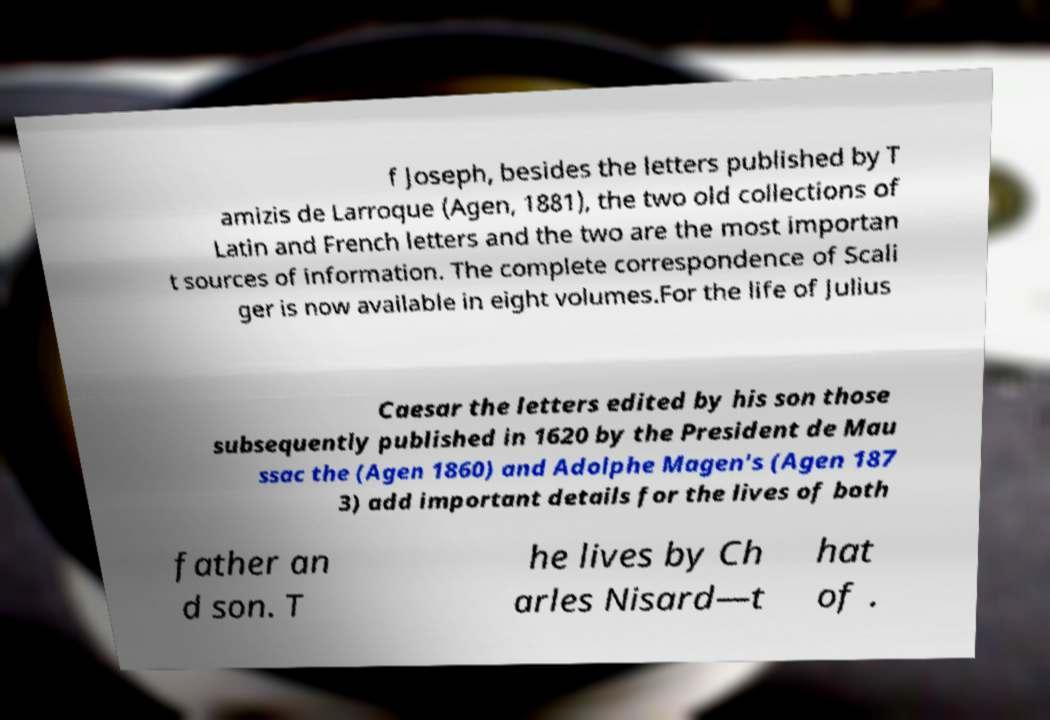Could you assist in decoding the text presented in this image and type it out clearly? f Joseph, besides the letters published by T amizis de Larroque (Agen, 1881), the two old collections of Latin and French letters and the two are the most importan t sources of information. The complete correspondence of Scali ger is now available in eight volumes.For the life of Julius Caesar the letters edited by his son those subsequently published in 1620 by the President de Mau ssac the (Agen 1860) and Adolphe Magen's (Agen 187 3) add important details for the lives of both father an d son. T he lives by Ch arles Nisard—t hat of . 